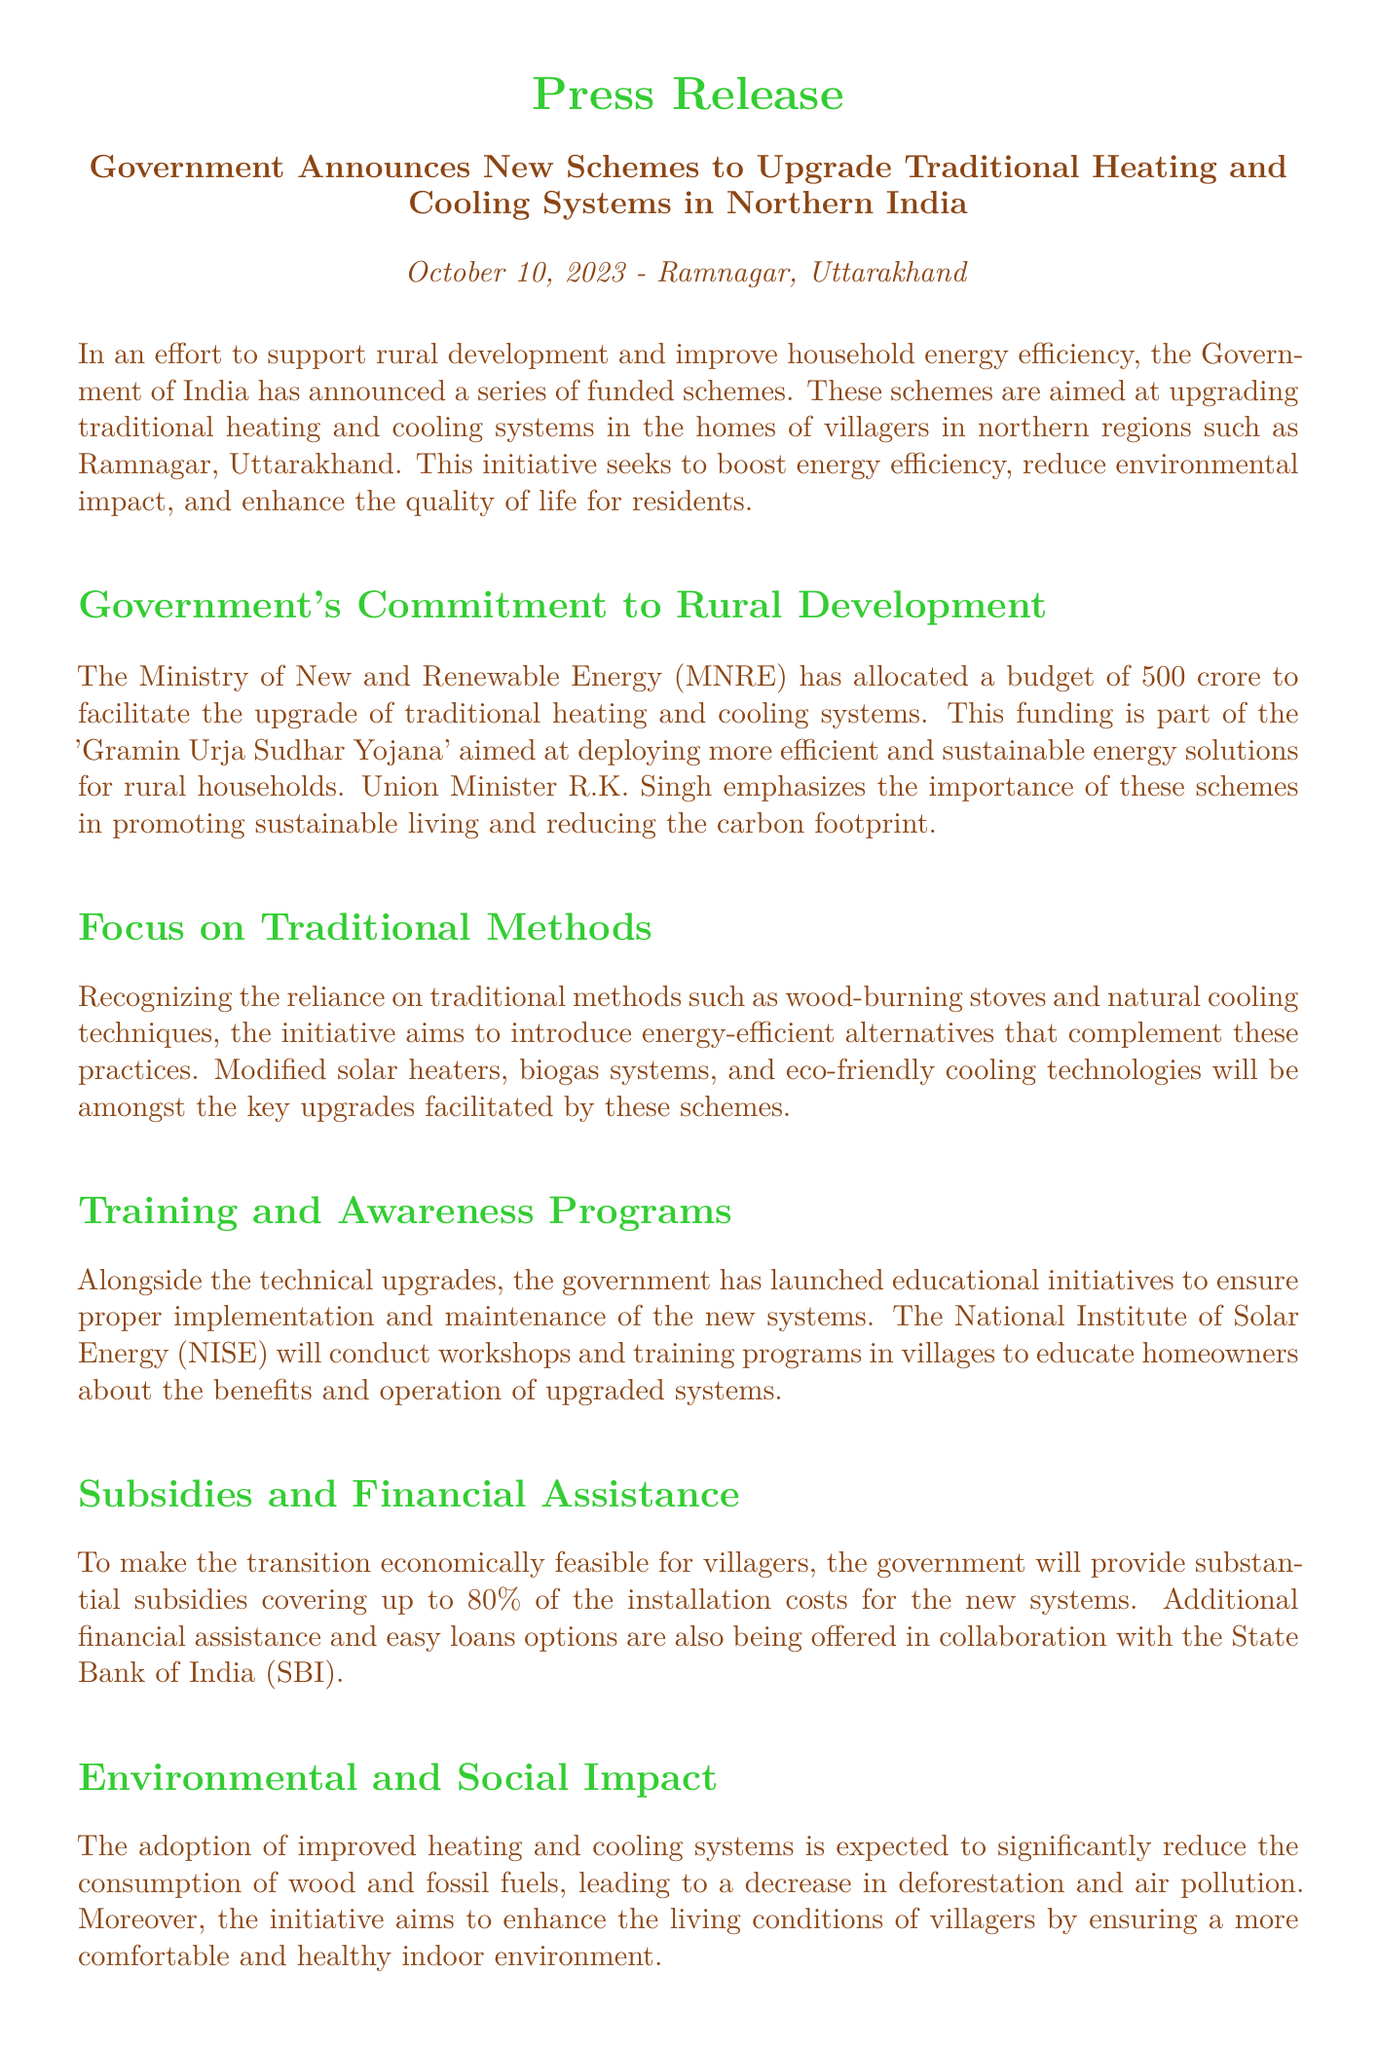What is the budget allocated for upgrading heating and cooling systems? The budget allocated by the Ministry of New and Renewable Energy is ₹500 crore.
Answer: ₹500 crore What is the name of the scheme mentioned? The scheme aimed at upgrading traditional heating and cooling systems is called 'Gramin Urja Sudhar Yojana'.
Answer: Gramin Urja Sudhar Yojana Who will conduct workshops in villages? The National Institute of Solar Energy (NISE) will conduct workshops and training programs in villages.
Answer: National Institute of Solar Energy (NISE) What is the percentage of installation cost covered by subsidies? The government will provide subsidies covering up to 80% of the installation costs for the new systems.
Answer: 80% What materials will be reduced through these improved systems? The adoption of improved heating and cooling systems is expected to significantly reduce the consumption of wood and fossil fuels.
Answer: Wood and fossil fuels Why is the government promoting this initiative? The initiative aims to boost energy efficiency, reduce environmental impact, and enhance the quality of life for residents.
Answer: Boost energy efficiency, reduce environmental impact, enhance quality of life What is the expected impact on indoor environments? The initiative aims to enhance the living conditions of villagers by ensuring a more comfortable and healthy indoor environment.
Answer: Comfortable and healthy indoor environment What is the role of the State Bank of India in this initiative? The State Bank of India (SBI) is collaborating to provide additional financial assistance and easy loan options.
Answer: Additional financial assistance, easy loans 